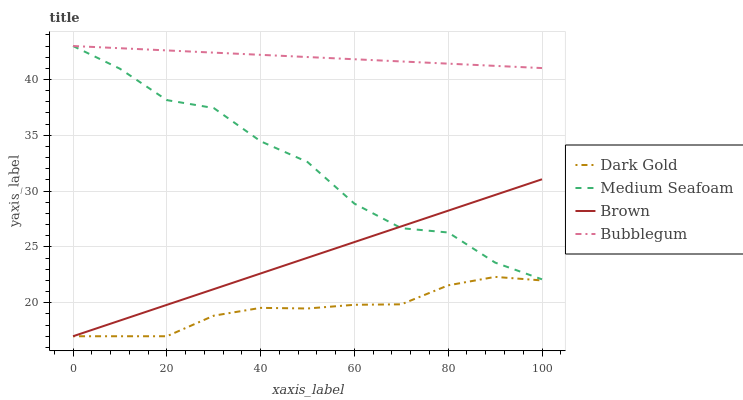Does Medium Seafoam have the minimum area under the curve?
Answer yes or no. No. Does Medium Seafoam have the maximum area under the curve?
Answer yes or no. No. Is Medium Seafoam the smoothest?
Answer yes or no. No. Is Bubblegum the roughest?
Answer yes or no. No. Does Medium Seafoam have the lowest value?
Answer yes or no. No. Does Dark Gold have the highest value?
Answer yes or no. No. Is Brown less than Bubblegum?
Answer yes or no. Yes. Is Medium Seafoam greater than Dark Gold?
Answer yes or no. Yes. Does Brown intersect Bubblegum?
Answer yes or no. No. 